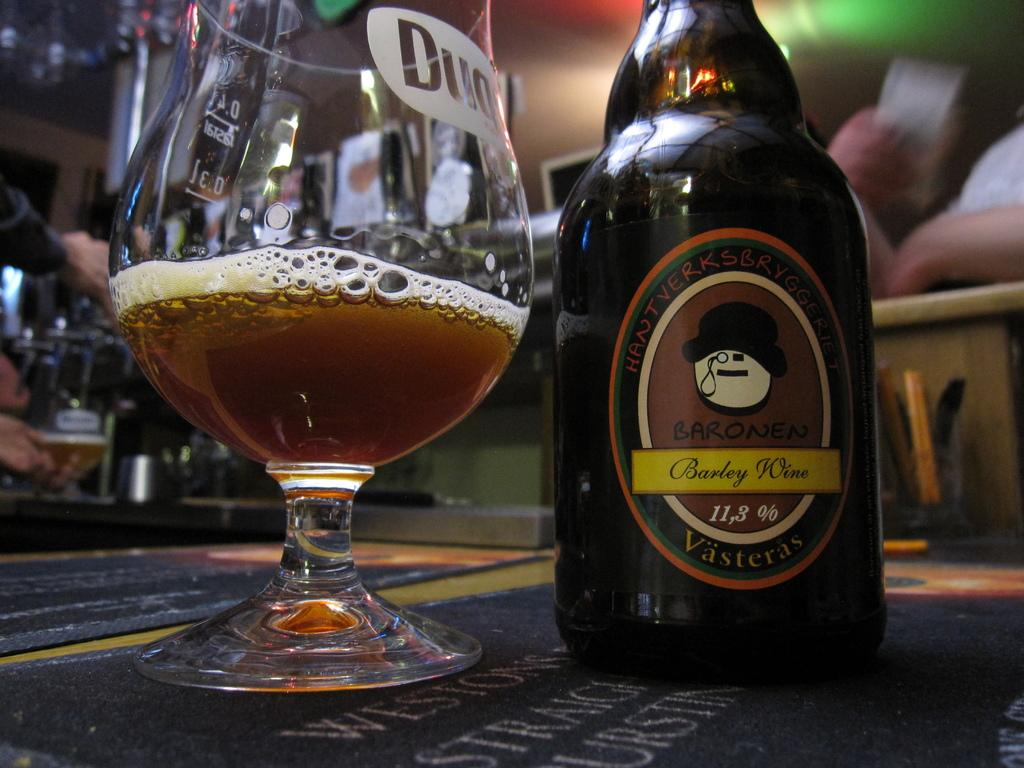<image>
Give a short and clear explanation of the subsequent image. A bottle of Vasteras beer sits on a table in a glass 